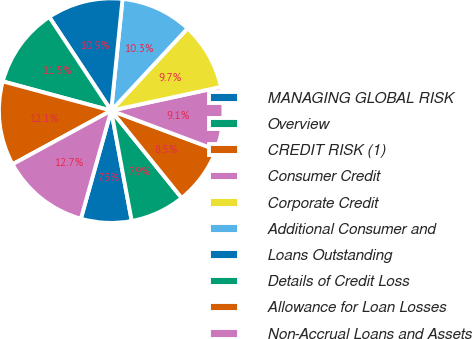<chart> <loc_0><loc_0><loc_500><loc_500><pie_chart><fcel>MANAGING GLOBAL RISK<fcel>Overview<fcel>CREDIT RISK (1)<fcel>Consumer Credit<fcel>Corporate Credit<fcel>Additional Consumer and<fcel>Loans Outstanding<fcel>Details of Credit Loss<fcel>Allowance for Loan Losses<fcel>Non-Accrual Loans and Assets<nl><fcel>7.28%<fcel>7.88%<fcel>8.49%<fcel>9.09%<fcel>9.7%<fcel>10.3%<fcel>10.91%<fcel>11.51%<fcel>12.12%<fcel>12.72%<nl></chart> 